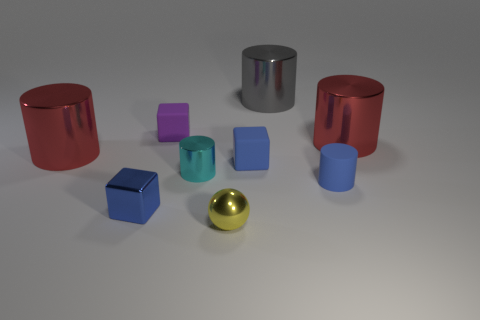There is a red shiny object that is to the left of the purple matte object; does it have the same shape as the large red object on the right side of the tiny cyan metal thing?
Your response must be concise. Yes. What is the size of the red shiny cylinder right of the small cyan cylinder?
Ensure brevity in your answer.  Large. What size is the red cylinder right of the red cylinder that is on the left side of the matte cylinder?
Ensure brevity in your answer.  Large. Is the number of cubes greater than the number of cyan metal things?
Ensure brevity in your answer.  Yes. Is the number of tiny yellow balls that are on the left side of the purple rubber thing greater than the number of cyan metal cylinders that are in front of the shiny sphere?
Ensure brevity in your answer.  No. How big is the metallic object that is both in front of the small cyan thing and behind the yellow sphere?
Make the answer very short. Small. How many red metallic objects are the same size as the blue metallic object?
Give a very brief answer. 0. What is the material of the cylinder that is the same color as the metallic cube?
Ensure brevity in your answer.  Rubber. There is a big red shiny thing that is on the right side of the tiny purple object; is it the same shape as the cyan object?
Offer a terse response. Yes. Are there fewer small yellow metal things that are to the right of the blue rubber cube than small cylinders?
Your response must be concise. Yes. 